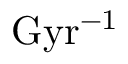Convert formula to latex. <formula><loc_0><loc_0><loc_500><loc_500>G y r ^ { - 1 }</formula> 